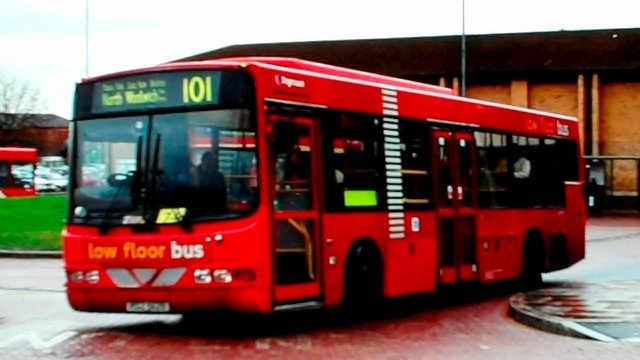Describe the objects in this image and their specific colors. I can see bus in azure, black, red, and maroon tones, bus in azure, black, red, brown, and lightblue tones, people in azure, teal, darkblue, navy, and purple tones, car in azure, lightblue, darkgray, and teal tones, and people in azure, black, darkblue, and teal tones in this image. 